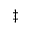Convert formula to latex. <formula><loc_0><loc_0><loc_500><loc_500>^ { \ddagger }</formula> 